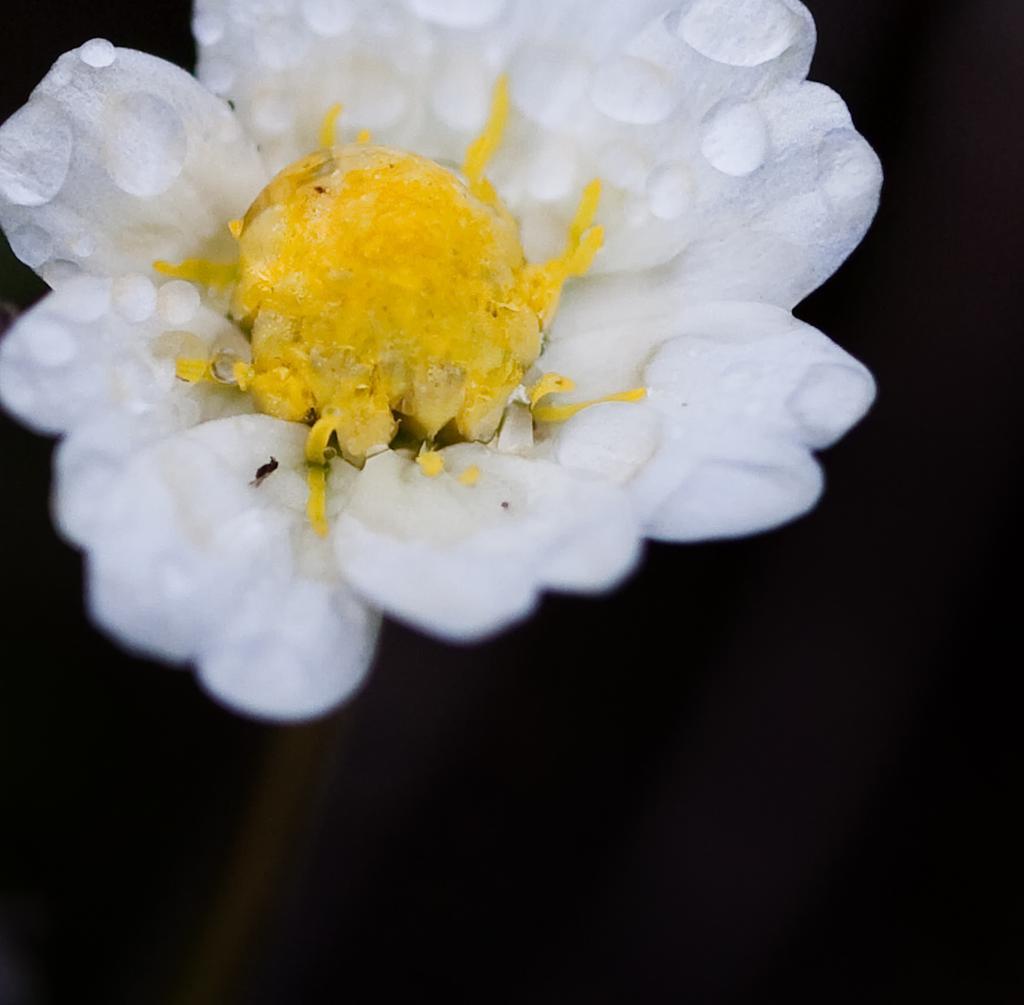How would you summarize this image in a sentence or two? In this picture there is a white color flower and there are water droplets on the flower. At the back there is a black background. 